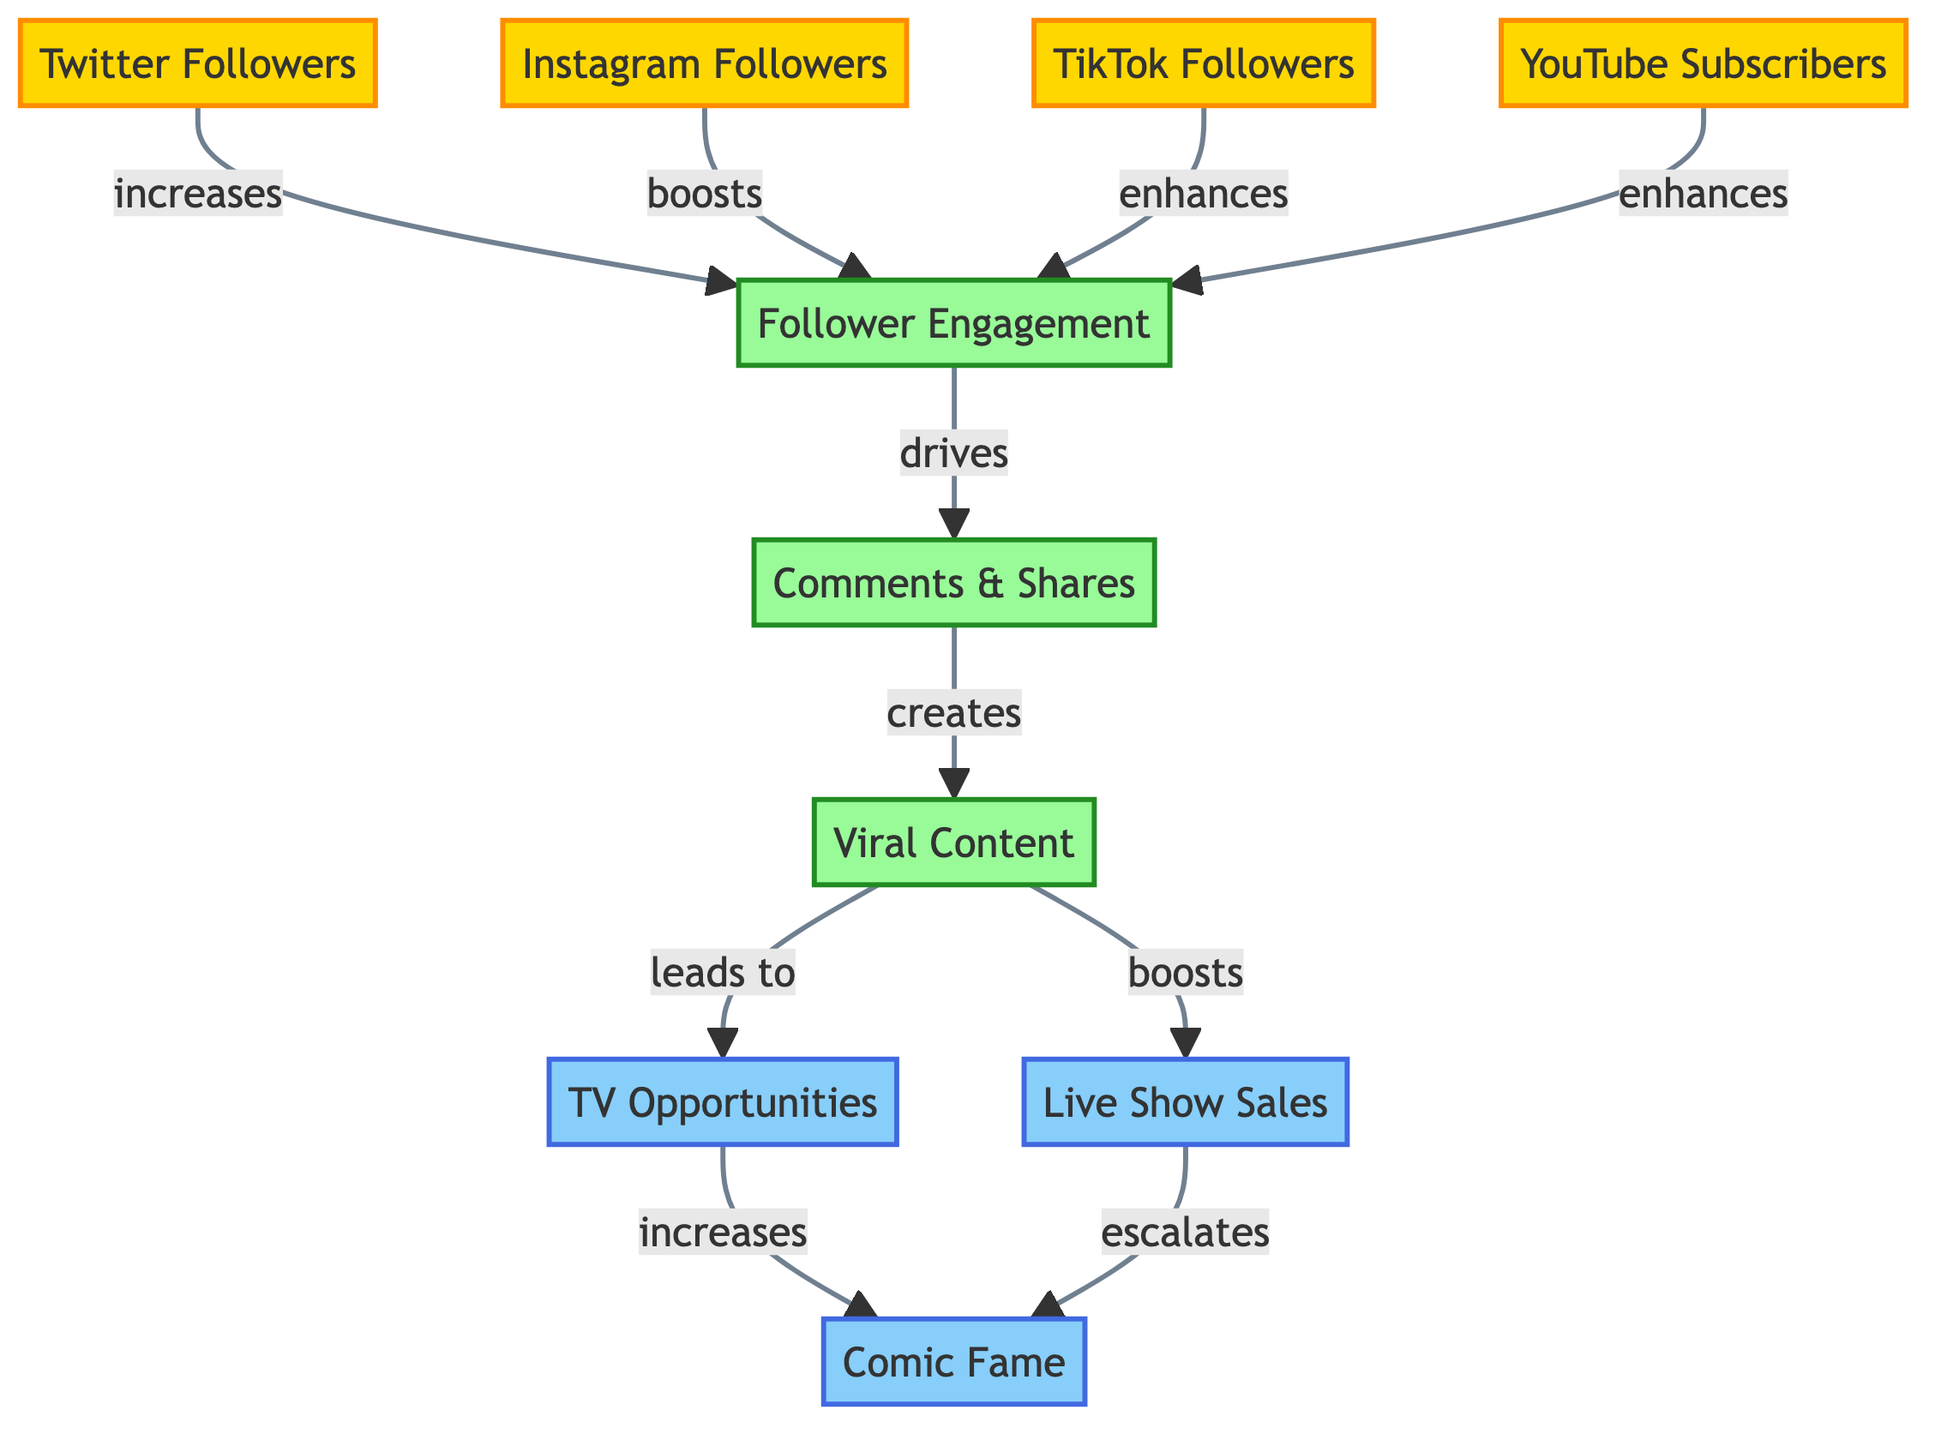What does an increase in Twitter Followers drive? According to the diagram, the flow indicates that an increase in Twitter Followers leads to higher Follower Engagement. This is a direct connection seen from the Twitter Followers node pointing towards the Follower Engagement node.
Answer: Follower Engagement Which social media platform leads to the highest likelihood of Viral Content generation? The diagram shows that Comments & Shares directly creates Viral Content. However, Follower Engagement, which is influenced by all the social media platforms, plays a crucial role. Thus, it isn't limited to just one social media platform but includes all as they enhance follower engagement that drives comments and shares leading to viral content.
Answer: All platforms What outcomes are directly influenced by Viral Content? The diagram clearly shows that Viral Content leads to two outcomes: TV Opportunities and Live Show Sales. Each of these outcomes directly follows the Viral Content node.
Answer: TV Opportunities and Live Show Sales How many primary social media platforms are represented in this diagram? The diagram includes four social media platforms: Twitter, Instagram, TikTok, and YouTube. Each platform is labeled as a distinct node in the social media category.
Answer: Four What outcome is affected by both TV Opportunities and Live Show Sales? The flow from both TV Opportunities and Live Show Sales indicates that they both lead to Comic Fame. This connection signifies that both outcomes contribute to the increase in Comic Fame.
Answer: Comic Fame If Comments & Shares were to decrease, what would be the subsequent effect? The diagram indicates that Comments & Shares create Viral Content. Therefore, a decrease in Comments & Shares would likely lead to a decrease in Viral Content. This is derived from the direct connection from Comments & Shares to the Viral Content node.
Answer: Decrease in Viral Content Which engagement type is emphasized as crucial for fostering comic fame? The diagram points to Follower Engagement as a central engagement type, as it is influenced by various social media platforms and directly drives Comments & Shares, which are foundational for generating Viral Content.
Answer: Follower Engagement What directly escalates Comic Fame? According to the diagram, Comic Fame increases due to two factors: TV Opportunities and Live Show Sales. Each of these factors plays a pivotal role in elevating the comic's fame.
Answer: TV Opportunities and Live Show Sales 